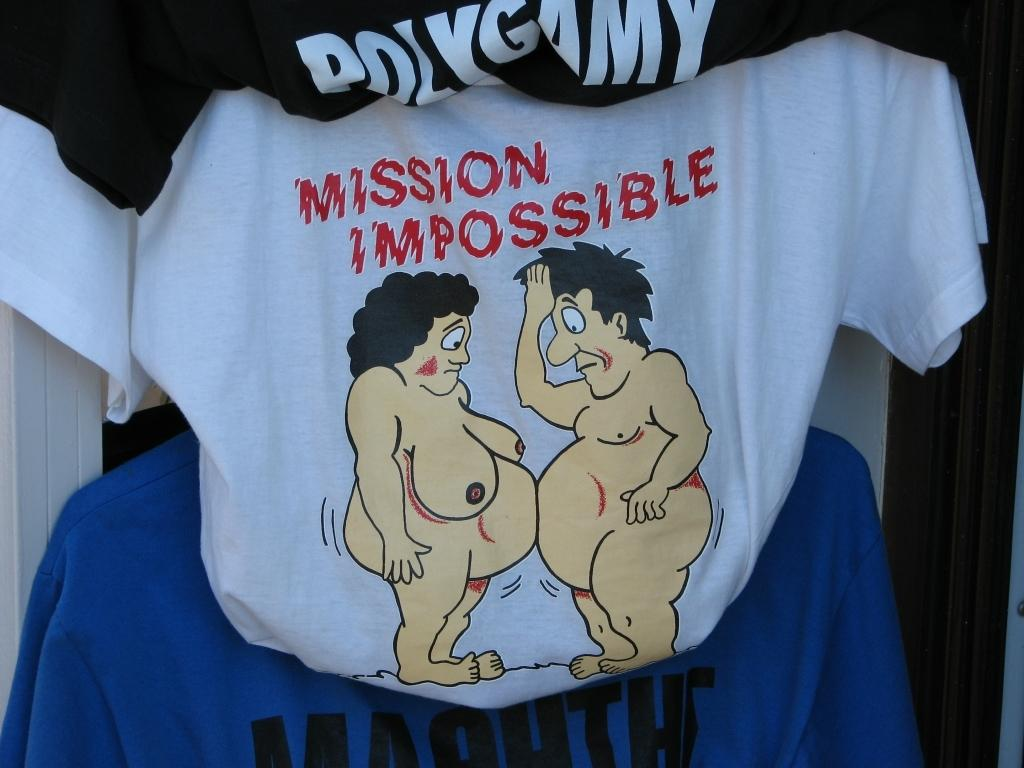<image>
Render a clear and concise summary of the photo. Shirt that have two naked cartoon people for mission impossible 